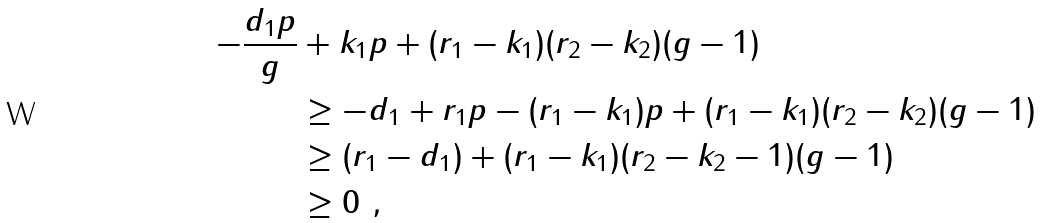Convert formula to latex. <formula><loc_0><loc_0><loc_500><loc_500>- \frac { d _ { 1 } p } { g } & + k _ { 1 } p + ( r _ { 1 } - k _ { 1 } ) ( r _ { 2 } - k _ { 2 } ) ( g - 1 ) \\ & \geq - d _ { 1 } + r _ { 1 } p - ( r _ { 1 } - k _ { 1 } ) p + ( r _ { 1 } - k _ { 1 } ) ( r _ { 2 } - k _ { 2 } ) ( g - 1 ) \\ & \geq ( r _ { 1 } - d _ { 1 } ) + ( r _ { 1 } - k _ { 1 } ) ( r _ { 2 } - k _ { 2 } - 1 ) ( g - 1 ) \\ & \geq 0 \ ,</formula> 